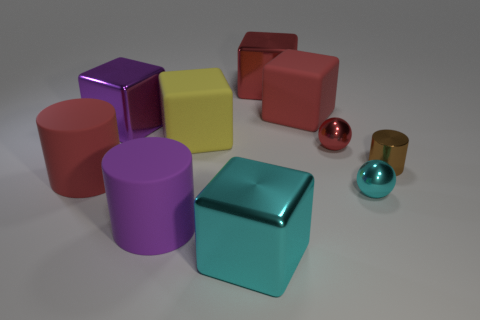Does the big metallic thing to the right of the big cyan shiny block have the same color as the block that is right of the large red metallic cube?
Your response must be concise. Yes. There is a small brown thing; are there any tiny red metallic balls right of it?
Provide a short and direct response. No. What number of red rubber objects are the same shape as the small brown thing?
Give a very brief answer. 1. The large metallic object that is on the right side of the big shiny block that is in front of the red object on the left side of the large red shiny thing is what color?
Your response must be concise. Red. Are the purple object in front of the large red cylinder and the cylinder right of the red ball made of the same material?
Provide a short and direct response. No. What number of objects are shiny blocks behind the big yellow cube or tiny red metal spheres?
Offer a very short reply. 3. How many things are tiny brown metallic objects or red things on the right side of the large cyan object?
Keep it short and to the point. 4. What number of cyan metallic balls are the same size as the red matte cylinder?
Your answer should be very brief. 0. Is the number of cylinders behind the purple metallic object less than the number of cubes that are in front of the large yellow object?
Make the answer very short. Yes. How many metal things are blue objects or cyan things?
Provide a succinct answer. 2. 